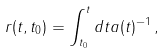<formula> <loc_0><loc_0><loc_500><loc_500>r ( t , t _ { 0 } ) = \int ^ { t } _ { t _ { 0 } } d t a ( t ) ^ { - 1 } \, ,</formula> 